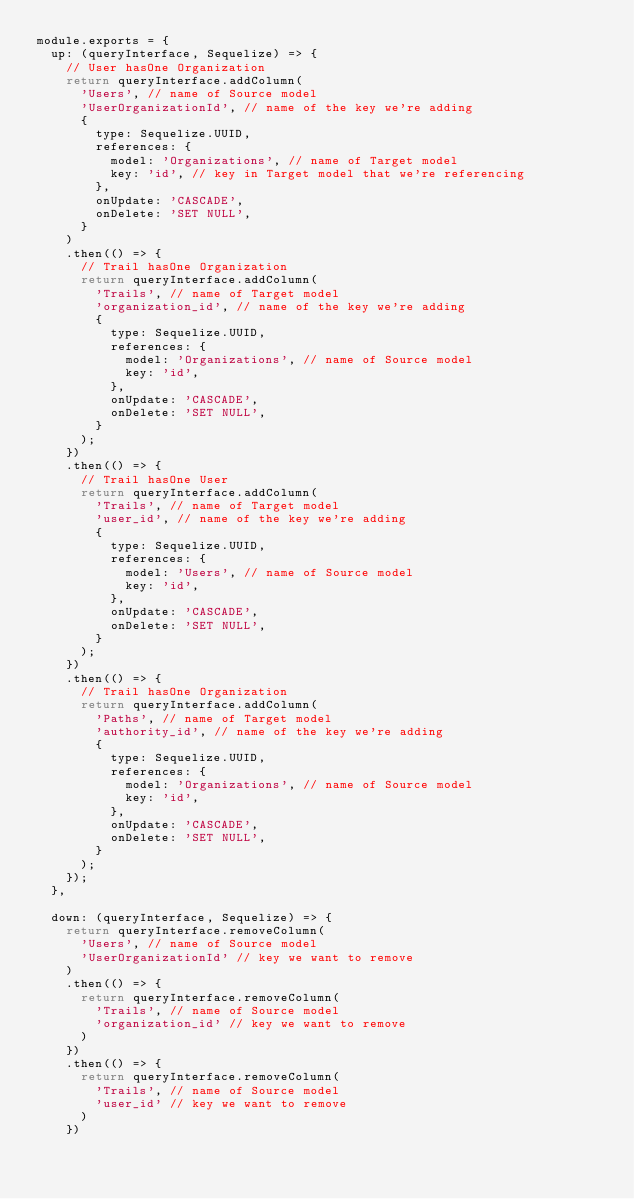Convert code to text. <code><loc_0><loc_0><loc_500><loc_500><_JavaScript_>module.exports = {
  up: (queryInterface, Sequelize) => {
    // User hasOne Organization
    return queryInterface.addColumn(
      'Users', // name of Source model
      'UserOrganizationId', // name of the key we're adding 
      {
        type: Sequelize.UUID,
        references: {
          model: 'Organizations', // name of Target model
          key: 'id', // key in Target model that we're referencing
        },
        onUpdate: 'CASCADE',
        onDelete: 'SET NULL',
      }
    )
    .then(() => {
      // Trail hasOne Organization
      return queryInterface.addColumn(
        'Trails', // name of Target model
        'organization_id', // name of the key we're adding
        {
          type: Sequelize.UUID,
          references: {
            model: 'Organizations', // name of Source model
            key: 'id',
          },
          onUpdate: 'CASCADE',
          onDelete: 'SET NULL',
        }
      );
    })
    .then(() => {
      // Trail hasOne User
      return queryInterface.addColumn(
        'Trails', // name of Target model
        'user_id', // name of the key we're adding
        {
          type: Sequelize.UUID,
          references: {
            model: 'Users', // name of Source model
            key: 'id',
          },
          onUpdate: 'CASCADE',
          onDelete: 'SET NULL',
        }
      );
    })
    .then(() => {
      // Trail hasOne Organization
      return queryInterface.addColumn(
        'Paths', // name of Target model
        'authority_id', // name of the key we're adding
        {
          type: Sequelize.UUID,
          references: {
            model: 'Organizations', // name of Source model
            key: 'id',
          },
          onUpdate: 'CASCADE',
          onDelete: 'SET NULL',
        }
      );
    });
  },

  down: (queryInterface, Sequelize) => {
    return queryInterface.removeColumn(
      'Users', // name of Source model
      'UserOrganizationId' // key we want to remove
    )
    .then(() => {
      return queryInterface.removeColumn(
        'Trails', // name of Source model
        'organization_id' // key we want to remove
      )
    })
    .then(() => {
      return queryInterface.removeColumn(
        'Trails', // name of Source model
        'user_id' // key we want to remove
      )
    })</code> 